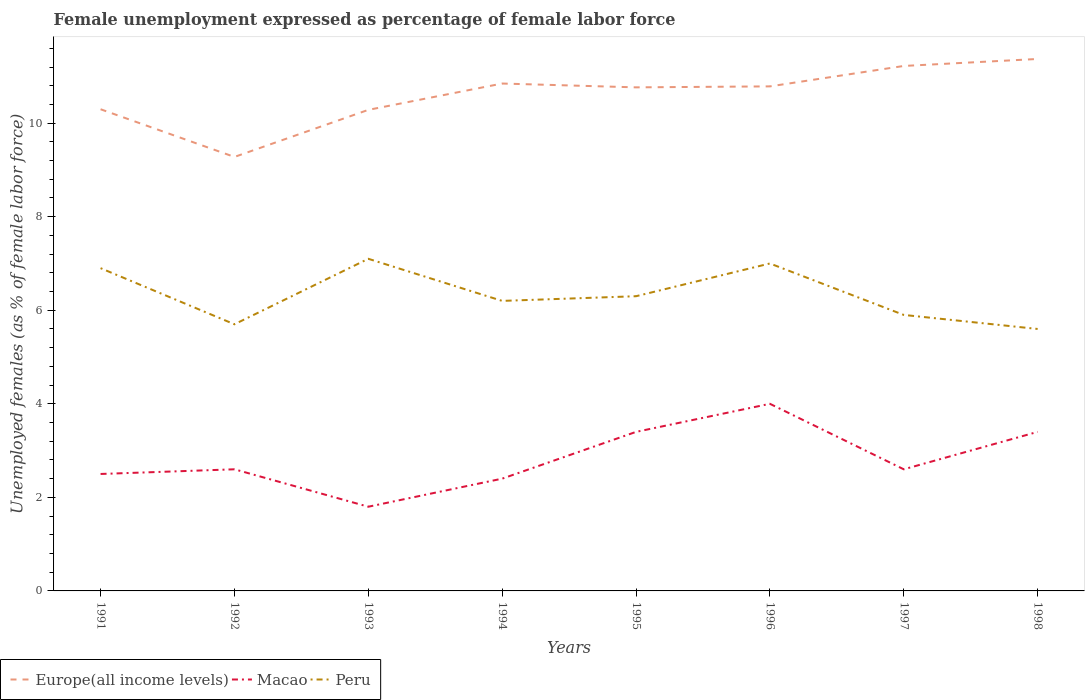How many different coloured lines are there?
Your answer should be compact. 3. Across all years, what is the maximum unemployment in females in in Europe(all income levels)?
Your answer should be compact. 9.28. What is the total unemployment in females in in Peru in the graph?
Make the answer very short. 1.2. What is the difference between the highest and the second highest unemployment in females in in Macao?
Keep it short and to the point. 2.2. What is the difference between the highest and the lowest unemployment in females in in Peru?
Provide a succinct answer. 3. How many years are there in the graph?
Your response must be concise. 8. Where does the legend appear in the graph?
Keep it short and to the point. Bottom left. How many legend labels are there?
Your answer should be very brief. 3. How are the legend labels stacked?
Provide a short and direct response. Horizontal. What is the title of the graph?
Keep it short and to the point. Female unemployment expressed as percentage of female labor force. What is the label or title of the X-axis?
Your answer should be compact. Years. What is the label or title of the Y-axis?
Keep it short and to the point. Unemployed females (as % of female labor force). What is the Unemployed females (as % of female labor force) in Europe(all income levels) in 1991?
Ensure brevity in your answer.  10.3. What is the Unemployed females (as % of female labor force) in Peru in 1991?
Make the answer very short. 6.9. What is the Unemployed females (as % of female labor force) of Europe(all income levels) in 1992?
Provide a succinct answer. 9.28. What is the Unemployed females (as % of female labor force) of Macao in 1992?
Offer a very short reply. 2.6. What is the Unemployed females (as % of female labor force) in Peru in 1992?
Your answer should be compact. 5.7. What is the Unemployed females (as % of female labor force) of Europe(all income levels) in 1993?
Give a very brief answer. 10.28. What is the Unemployed females (as % of female labor force) in Macao in 1993?
Ensure brevity in your answer.  1.8. What is the Unemployed females (as % of female labor force) of Peru in 1993?
Offer a terse response. 7.1. What is the Unemployed females (as % of female labor force) of Europe(all income levels) in 1994?
Your answer should be compact. 10.85. What is the Unemployed females (as % of female labor force) in Macao in 1994?
Offer a terse response. 2.4. What is the Unemployed females (as % of female labor force) in Peru in 1994?
Provide a short and direct response. 6.2. What is the Unemployed females (as % of female labor force) in Europe(all income levels) in 1995?
Offer a very short reply. 10.76. What is the Unemployed females (as % of female labor force) in Macao in 1995?
Offer a terse response. 3.4. What is the Unemployed females (as % of female labor force) of Peru in 1995?
Your answer should be very brief. 6.3. What is the Unemployed females (as % of female labor force) in Europe(all income levels) in 1996?
Offer a very short reply. 10.79. What is the Unemployed females (as % of female labor force) in Europe(all income levels) in 1997?
Keep it short and to the point. 11.22. What is the Unemployed females (as % of female labor force) in Macao in 1997?
Your answer should be very brief. 2.6. What is the Unemployed females (as % of female labor force) in Peru in 1997?
Keep it short and to the point. 5.9. What is the Unemployed females (as % of female labor force) in Europe(all income levels) in 1998?
Provide a short and direct response. 11.37. What is the Unemployed females (as % of female labor force) in Macao in 1998?
Provide a short and direct response. 3.4. What is the Unemployed females (as % of female labor force) of Peru in 1998?
Your answer should be very brief. 5.6. Across all years, what is the maximum Unemployed females (as % of female labor force) in Europe(all income levels)?
Make the answer very short. 11.37. Across all years, what is the maximum Unemployed females (as % of female labor force) in Peru?
Provide a succinct answer. 7.1. Across all years, what is the minimum Unemployed females (as % of female labor force) of Europe(all income levels)?
Your answer should be very brief. 9.28. Across all years, what is the minimum Unemployed females (as % of female labor force) of Macao?
Keep it short and to the point. 1.8. Across all years, what is the minimum Unemployed females (as % of female labor force) in Peru?
Offer a very short reply. 5.6. What is the total Unemployed females (as % of female labor force) of Europe(all income levels) in the graph?
Keep it short and to the point. 84.85. What is the total Unemployed females (as % of female labor force) in Macao in the graph?
Give a very brief answer. 22.7. What is the total Unemployed females (as % of female labor force) of Peru in the graph?
Ensure brevity in your answer.  50.7. What is the difference between the Unemployed females (as % of female labor force) in Europe(all income levels) in 1991 and that in 1992?
Provide a succinct answer. 1.02. What is the difference between the Unemployed females (as % of female labor force) of Europe(all income levels) in 1991 and that in 1993?
Offer a very short reply. 0.01. What is the difference between the Unemployed females (as % of female labor force) of Macao in 1991 and that in 1993?
Your answer should be very brief. 0.7. What is the difference between the Unemployed females (as % of female labor force) of Europe(all income levels) in 1991 and that in 1994?
Your response must be concise. -0.55. What is the difference between the Unemployed females (as % of female labor force) in Macao in 1991 and that in 1994?
Give a very brief answer. 0.1. What is the difference between the Unemployed females (as % of female labor force) of Europe(all income levels) in 1991 and that in 1995?
Ensure brevity in your answer.  -0.47. What is the difference between the Unemployed females (as % of female labor force) of Macao in 1991 and that in 1995?
Give a very brief answer. -0.9. What is the difference between the Unemployed females (as % of female labor force) in Peru in 1991 and that in 1995?
Keep it short and to the point. 0.6. What is the difference between the Unemployed females (as % of female labor force) in Europe(all income levels) in 1991 and that in 1996?
Provide a succinct answer. -0.49. What is the difference between the Unemployed females (as % of female labor force) of Macao in 1991 and that in 1996?
Offer a very short reply. -1.5. What is the difference between the Unemployed females (as % of female labor force) of Peru in 1991 and that in 1996?
Offer a terse response. -0.1. What is the difference between the Unemployed females (as % of female labor force) in Europe(all income levels) in 1991 and that in 1997?
Your response must be concise. -0.93. What is the difference between the Unemployed females (as % of female labor force) of Macao in 1991 and that in 1997?
Your answer should be very brief. -0.1. What is the difference between the Unemployed females (as % of female labor force) of Europe(all income levels) in 1991 and that in 1998?
Make the answer very short. -1.07. What is the difference between the Unemployed females (as % of female labor force) in Europe(all income levels) in 1992 and that in 1993?
Your response must be concise. -1.01. What is the difference between the Unemployed females (as % of female labor force) of Macao in 1992 and that in 1993?
Provide a succinct answer. 0.8. What is the difference between the Unemployed females (as % of female labor force) of Europe(all income levels) in 1992 and that in 1994?
Your answer should be very brief. -1.57. What is the difference between the Unemployed females (as % of female labor force) of Peru in 1992 and that in 1994?
Offer a very short reply. -0.5. What is the difference between the Unemployed females (as % of female labor force) in Europe(all income levels) in 1992 and that in 1995?
Provide a short and direct response. -1.49. What is the difference between the Unemployed females (as % of female labor force) of Europe(all income levels) in 1992 and that in 1996?
Provide a succinct answer. -1.51. What is the difference between the Unemployed females (as % of female labor force) in Macao in 1992 and that in 1996?
Your answer should be very brief. -1.4. What is the difference between the Unemployed females (as % of female labor force) of Europe(all income levels) in 1992 and that in 1997?
Give a very brief answer. -1.95. What is the difference between the Unemployed females (as % of female labor force) in Macao in 1992 and that in 1997?
Provide a succinct answer. 0. What is the difference between the Unemployed females (as % of female labor force) in Europe(all income levels) in 1992 and that in 1998?
Give a very brief answer. -2.09. What is the difference between the Unemployed females (as % of female labor force) of Europe(all income levels) in 1993 and that in 1994?
Offer a terse response. -0.56. What is the difference between the Unemployed females (as % of female labor force) in Europe(all income levels) in 1993 and that in 1995?
Keep it short and to the point. -0.48. What is the difference between the Unemployed females (as % of female labor force) of Macao in 1993 and that in 1995?
Give a very brief answer. -1.6. What is the difference between the Unemployed females (as % of female labor force) in Europe(all income levels) in 1993 and that in 1996?
Keep it short and to the point. -0.5. What is the difference between the Unemployed females (as % of female labor force) of Peru in 1993 and that in 1996?
Provide a succinct answer. 0.1. What is the difference between the Unemployed females (as % of female labor force) in Europe(all income levels) in 1993 and that in 1997?
Provide a succinct answer. -0.94. What is the difference between the Unemployed females (as % of female labor force) of Europe(all income levels) in 1993 and that in 1998?
Your answer should be compact. -1.09. What is the difference between the Unemployed females (as % of female labor force) of Macao in 1993 and that in 1998?
Provide a succinct answer. -1.6. What is the difference between the Unemployed females (as % of female labor force) in Peru in 1993 and that in 1998?
Your response must be concise. 1.5. What is the difference between the Unemployed females (as % of female labor force) of Europe(all income levels) in 1994 and that in 1995?
Your response must be concise. 0.08. What is the difference between the Unemployed females (as % of female labor force) in Macao in 1994 and that in 1995?
Your answer should be compact. -1. What is the difference between the Unemployed females (as % of female labor force) in Peru in 1994 and that in 1995?
Make the answer very short. -0.1. What is the difference between the Unemployed females (as % of female labor force) in Europe(all income levels) in 1994 and that in 1996?
Your response must be concise. 0.06. What is the difference between the Unemployed females (as % of female labor force) of Macao in 1994 and that in 1996?
Your answer should be very brief. -1.6. What is the difference between the Unemployed females (as % of female labor force) in Europe(all income levels) in 1994 and that in 1997?
Your answer should be very brief. -0.38. What is the difference between the Unemployed females (as % of female labor force) in Peru in 1994 and that in 1997?
Offer a terse response. 0.3. What is the difference between the Unemployed females (as % of female labor force) in Europe(all income levels) in 1994 and that in 1998?
Give a very brief answer. -0.53. What is the difference between the Unemployed females (as % of female labor force) in Peru in 1994 and that in 1998?
Provide a succinct answer. 0.6. What is the difference between the Unemployed females (as % of female labor force) of Europe(all income levels) in 1995 and that in 1996?
Ensure brevity in your answer.  -0.02. What is the difference between the Unemployed females (as % of female labor force) in Macao in 1995 and that in 1996?
Provide a short and direct response. -0.6. What is the difference between the Unemployed females (as % of female labor force) of Peru in 1995 and that in 1996?
Provide a succinct answer. -0.7. What is the difference between the Unemployed females (as % of female labor force) in Europe(all income levels) in 1995 and that in 1997?
Your answer should be compact. -0.46. What is the difference between the Unemployed females (as % of female labor force) in Macao in 1995 and that in 1997?
Your answer should be very brief. 0.8. What is the difference between the Unemployed females (as % of female labor force) of Europe(all income levels) in 1995 and that in 1998?
Offer a terse response. -0.61. What is the difference between the Unemployed females (as % of female labor force) in Europe(all income levels) in 1996 and that in 1997?
Your answer should be very brief. -0.44. What is the difference between the Unemployed females (as % of female labor force) in Peru in 1996 and that in 1997?
Your response must be concise. 1.1. What is the difference between the Unemployed females (as % of female labor force) of Europe(all income levels) in 1996 and that in 1998?
Offer a terse response. -0.59. What is the difference between the Unemployed females (as % of female labor force) in Europe(all income levels) in 1997 and that in 1998?
Give a very brief answer. -0.15. What is the difference between the Unemployed females (as % of female labor force) in Macao in 1997 and that in 1998?
Offer a terse response. -0.8. What is the difference between the Unemployed females (as % of female labor force) in Peru in 1997 and that in 1998?
Give a very brief answer. 0.3. What is the difference between the Unemployed females (as % of female labor force) in Europe(all income levels) in 1991 and the Unemployed females (as % of female labor force) in Macao in 1992?
Keep it short and to the point. 7.7. What is the difference between the Unemployed females (as % of female labor force) of Europe(all income levels) in 1991 and the Unemployed females (as % of female labor force) of Peru in 1992?
Your response must be concise. 4.6. What is the difference between the Unemployed females (as % of female labor force) of Macao in 1991 and the Unemployed females (as % of female labor force) of Peru in 1992?
Offer a very short reply. -3.2. What is the difference between the Unemployed females (as % of female labor force) of Europe(all income levels) in 1991 and the Unemployed females (as % of female labor force) of Macao in 1993?
Ensure brevity in your answer.  8.5. What is the difference between the Unemployed females (as % of female labor force) of Europe(all income levels) in 1991 and the Unemployed females (as % of female labor force) of Peru in 1993?
Provide a short and direct response. 3.2. What is the difference between the Unemployed females (as % of female labor force) in Europe(all income levels) in 1991 and the Unemployed females (as % of female labor force) in Macao in 1994?
Your answer should be very brief. 7.9. What is the difference between the Unemployed females (as % of female labor force) in Europe(all income levels) in 1991 and the Unemployed females (as % of female labor force) in Peru in 1994?
Offer a very short reply. 4.1. What is the difference between the Unemployed females (as % of female labor force) in Macao in 1991 and the Unemployed females (as % of female labor force) in Peru in 1994?
Your answer should be very brief. -3.7. What is the difference between the Unemployed females (as % of female labor force) of Europe(all income levels) in 1991 and the Unemployed females (as % of female labor force) of Macao in 1995?
Offer a very short reply. 6.9. What is the difference between the Unemployed females (as % of female labor force) of Europe(all income levels) in 1991 and the Unemployed females (as % of female labor force) of Peru in 1995?
Give a very brief answer. 4. What is the difference between the Unemployed females (as % of female labor force) of Europe(all income levels) in 1991 and the Unemployed females (as % of female labor force) of Macao in 1996?
Ensure brevity in your answer.  6.3. What is the difference between the Unemployed females (as % of female labor force) of Europe(all income levels) in 1991 and the Unemployed females (as % of female labor force) of Peru in 1996?
Ensure brevity in your answer.  3.3. What is the difference between the Unemployed females (as % of female labor force) of Macao in 1991 and the Unemployed females (as % of female labor force) of Peru in 1996?
Offer a very short reply. -4.5. What is the difference between the Unemployed females (as % of female labor force) in Europe(all income levels) in 1991 and the Unemployed females (as % of female labor force) in Macao in 1997?
Your response must be concise. 7.7. What is the difference between the Unemployed females (as % of female labor force) of Europe(all income levels) in 1991 and the Unemployed females (as % of female labor force) of Peru in 1997?
Provide a succinct answer. 4.4. What is the difference between the Unemployed females (as % of female labor force) in Europe(all income levels) in 1991 and the Unemployed females (as % of female labor force) in Macao in 1998?
Offer a very short reply. 6.9. What is the difference between the Unemployed females (as % of female labor force) in Europe(all income levels) in 1991 and the Unemployed females (as % of female labor force) in Peru in 1998?
Offer a terse response. 4.7. What is the difference between the Unemployed females (as % of female labor force) of Europe(all income levels) in 1992 and the Unemployed females (as % of female labor force) of Macao in 1993?
Make the answer very short. 7.48. What is the difference between the Unemployed females (as % of female labor force) of Europe(all income levels) in 1992 and the Unemployed females (as % of female labor force) of Peru in 1993?
Provide a succinct answer. 2.18. What is the difference between the Unemployed females (as % of female labor force) in Europe(all income levels) in 1992 and the Unemployed females (as % of female labor force) in Macao in 1994?
Provide a succinct answer. 6.88. What is the difference between the Unemployed females (as % of female labor force) in Europe(all income levels) in 1992 and the Unemployed females (as % of female labor force) in Peru in 1994?
Your response must be concise. 3.08. What is the difference between the Unemployed females (as % of female labor force) in Europe(all income levels) in 1992 and the Unemployed females (as % of female labor force) in Macao in 1995?
Your answer should be very brief. 5.88. What is the difference between the Unemployed females (as % of female labor force) in Europe(all income levels) in 1992 and the Unemployed females (as % of female labor force) in Peru in 1995?
Make the answer very short. 2.98. What is the difference between the Unemployed females (as % of female labor force) of Europe(all income levels) in 1992 and the Unemployed females (as % of female labor force) of Macao in 1996?
Make the answer very short. 5.28. What is the difference between the Unemployed females (as % of female labor force) in Europe(all income levels) in 1992 and the Unemployed females (as % of female labor force) in Peru in 1996?
Your response must be concise. 2.28. What is the difference between the Unemployed females (as % of female labor force) of Macao in 1992 and the Unemployed females (as % of female labor force) of Peru in 1996?
Make the answer very short. -4.4. What is the difference between the Unemployed females (as % of female labor force) in Europe(all income levels) in 1992 and the Unemployed females (as % of female labor force) in Macao in 1997?
Your answer should be very brief. 6.68. What is the difference between the Unemployed females (as % of female labor force) of Europe(all income levels) in 1992 and the Unemployed females (as % of female labor force) of Peru in 1997?
Your answer should be compact. 3.38. What is the difference between the Unemployed females (as % of female labor force) in Europe(all income levels) in 1992 and the Unemployed females (as % of female labor force) in Macao in 1998?
Provide a short and direct response. 5.88. What is the difference between the Unemployed females (as % of female labor force) of Europe(all income levels) in 1992 and the Unemployed females (as % of female labor force) of Peru in 1998?
Your answer should be very brief. 3.68. What is the difference between the Unemployed females (as % of female labor force) in Macao in 1992 and the Unemployed females (as % of female labor force) in Peru in 1998?
Provide a short and direct response. -3. What is the difference between the Unemployed females (as % of female labor force) of Europe(all income levels) in 1993 and the Unemployed females (as % of female labor force) of Macao in 1994?
Your answer should be compact. 7.88. What is the difference between the Unemployed females (as % of female labor force) of Europe(all income levels) in 1993 and the Unemployed females (as % of female labor force) of Peru in 1994?
Provide a succinct answer. 4.08. What is the difference between the Unemployed females (as % of female labor force) in Europe(all income levels) in 1993 and the Unemployed females (as % of female labor force) in Macao in 1995?
Provide a succinct answer. 6.88. What is the difference between the Unemployed females (as % of female labor force) in Europe(all income levels) in 1993 and the Unemployed females (as % of female labor force) in Peru in 1995?
Ensure brevity in your answer.  3.98. What is the difference between the Unemployed females (as % of female labor force) in Europe(all income levels) in 1993 and the Unemployed females (as % of female labor force) in Macao in 1996?
Provide a succinct answer. 6.28. What is the difference between the Unemployed females (as % of female labor force) in Europe(all income levels) in 1993 and the Unemployed females (as % of female labor force) in Peru in 1996?
Ensure brevity in your answer.  3.28. What is the difference between the Unemployed females (as % of female labor force) in Europe(all income levels) in 1993 and the Unemployed females (as % of female labor force) in Macao in 1997?
Ensure brevity in your answer.  7.68. What is the difference between the Unemployed females (as % of female labor force) of Europe(all income levels) in 1993 and the Unemployed females (as % of female labor force) of Peru in 1997?
Provide a succinct answer. 4.38. What is the difference between the Unemployed females (as % of female labor force) in Europe(all income levels) in 1993 and the Unemployed females (as % of female labor force) in Macao in 1998?
Provide a succinct answer. 6.88. What is the difference between the Unemployed females (as % of female labor force) in Europe(all income levels) in 1993 and the Unemployed females (as % of female labor force) in Peru in 1998?
Offer a very short reply. 4.68. What is the difference between the Unemployed females (as % of female labor force) in Europe(all income levels) in 1994 and the Unemployed females (as % of female labor force) in Macao in 1995?
Provide a succinct answer. 7.45. What is the difference between the Unemployed females (as % of female labor force) in Europe(all income levels) in 1994 and the Unemployed females (as % of female labor force) in Peru in 1995?
Ensure brevity in your answer.  4.55. What is the difference between the Unemployed females (as % of female labor force) of Macao in 1994 and the Unemployed females (as % of female labor force) of Peru in 1995?
Keep it short and to the point. -3.9. What is the difference between the Unemployed females (as % of female labor force) of Europe(all income levels) in 1994 and the Unemployed females (as % of female labor force) of Macao in 1996?
Ensure brevity in your answer.  6.85. What is the difference between the Unemployed females (as % of female labor force) in Europe(all income levels) in 1994 and the Unemployed females (as % of female labor force) in Peru in 1996?
Keep it short and to the point. 3.85. What is the difference between the Unemployed females (as % of female labor force) in Europe(all income levels) in 1994 and the Unemployed females (as % of female labor force) in Macao in 1997?
Your response must be concise. 8.25. What is the difference between the Unemployed females (as % of female labor force) in Europe(all income levels) in 1994 and the Unemployed females (as % of female labor force) in Peru in 1997?
Your answer should be compact. 4.95. What is the difference between the Unemployed females (as % of female labor force) in Europe(all income levels) in 1994 and the Unemployed females (as % of female labor force) in Macao in 1998?
Your answer should be very brief. 7.45. What is the difference between the Unemployed females (as % of female labor force) in Europe(all income levels) in 1994 and the Unemployed females (as % of female labor force) in Peru in 1998?
Your answer should be compact. 5.25. What is the difference between the Unemployed females (as % of female labor force) of Europe(all income levels) in 1995 and the Unemployed females (as % of female labor force) of Macao in 1996?
Keep it short and to the point. 6.76. What is the difference between the Unemployed females (as % of female labor force) in Europe(all income levels) in 1995 and the Unemployed females (as % of female labor force) in Peru in 1996?
Your answer should be compact. 3.76. What is the difference between the Unemployed females (as % of female labor force) of Europe(all income levels) in 1995 and the Unemployed females (as % of female labor force) of Macao in 1997?
Give a very brief answer. 8.16. What is the difference between the Unemployed females (as % of female labor force) of Europe(all income levels) in 1995 and the Unemployed females (as % of female labor force) of Peru in 1997?
Ensure brevity in your answer.  4.86. What is the difference between the Unemployed females (as % of female labor force) of Macao in 1995 and the Unemployed females (as % of female labor force) of Peru in 1997?
Offer a very short reply. -2.5. What is the difference between the Unemployed females (as % of female labor force) of Europe(all income levels) in 1995 and the Unemployed females (as % of female labor force) of Macao in 1998?
Give a very brief answer. 7.36. What is the difference between the Unemployed females (as % of female labor force) of Europe(all income levels) in 1995 and the Unemployed females (as % of female labor force) of Peru in 1998?
Your response must be concise. 5.16. What is the difference between the Unemployed females (as % of female labor force) of Macao in 1995 and the Unemployed females (as % of female labor force) of Peru in 1998?
Your response must be concise. -2.2. What is the difference between the Unemployed females (as % of female labor force) of Europe(all income levels) in 1996 and the Unemployed females (as % of female labor force) of Macao in 1997?
Your response must be concise. 8.19. What is the difference between the Unemployed females (as % of female labor force) in Europe(all income levels) in 1996 and the Unemployed females (as % of female labor force) in Peru in 1997?
Your response must be concise. 4.89. What is the difference between the Unemployed females (as % of female labor force) in Europe(all income levels) in 1996 and the Unemployed females (as % of female labor force) in Macao in 1998?
Your response must be concise. 7.39. What is the difference between the Unemployed females (as % of female labor force) of Europe(all income levels) in 1996 and the Unemployed females (as % of female labor force) of Peru in 1998?
Make the answer very short. 5.19. What is the difference between the Unemployed females (as % of female labor force) of Macao in 1996 and the Unemployed females (as % of female labor force) of Peru in 1998?
Make the answer very short. -1.6. What is the difference between the Unemployed females (as % of female labor force) in Europe(all income levels) in 1997 and the Unemployed females (as % of female labor force) in Macao in 1998?
Provide a succinct answer. 7.82. What is the difference between the Unemployed females (as % of female labor force) of Europe(all income levels) in 1997 and the Unemployed females (as % of female labor force) of Peru in 1998?
Your answer should be compact. 5.62. What is the average Unemployed females (as % of female labor force) of Europe(all income levels) per year?
Offer a very short reply. 10.61. What is the average Unemployed females (as % of female labor force) of Macao per year?
Your answer should be compact. 2.84. What is the average Unemployed females (as % of female labor force) in Peru per year?
Give a very brief answer. 6.34. In the year 1991, what is the difference between the Unemployed females (as % of female labor force) of Europe(all income levels) and Unemployed females (as % of female labor force) of Macao?
Give a very brief answer. 7.8. In the year 1991, what is the difference between the Unemployed females (as % of female labor force) of Europe(all income levels) and Unemployed females (as % of female labor force) of Peru?
Your answer should be compact. 3.4. In the year 1991, what is the difference between the Unemployed females (as % of female labor force) of Macao and Unemployed females (as % of female labor force) of Peru?
Offer a very short reply. -4.4. In the year 1992, what is the difference between the Unemployed females (as % of female labor force) in Europe(all income levels) and Unemployed females (as % of female labor force) in Macao?
Give a very brief answer. 6.68. In the year 1992, what is the difference between the Unemployed females (as % of female labor force) in Europe(all income levels) and Unemployed females (as % of female labor force) in Peru?
Your response must be concise. 3.58. In the year 1993, what is the difference between the Unemployed females (as % of female labor force) in Europe(all income levels) and Unemployed females (as % of female labor force) in Macao?
Your response must be concise. 8.48. In the year 1993, what is the difference between the Unemployed females (as % of female labor force) in Europe(all income levels) and Unemployed females (as % of female labor force) in Peru?
Provide a succinct answer. 3.18. In the year 1993, what is the difference between the Unemployed females (as % of female labor force) of Macao and Unemployed females (as % of female labor force) of Peru?
Give a very brief answer. -5.3. In the year 1994, what is the difference between the Unemployed females (as % of female labor force) in Europe(all income levels) and Unemployed females (as % of female labor force) in Macao?
Your answer should be compact. 8.45. In the year 1994, what is the difference between the Unemployed females (as % of female labor force) of Europe(all income levels) and Unemployed females (as % of female labor force) of Peru?
Give a very brief answer. 4.65. In the year 1994, what is the difference between the Unemployed females (as % of female labor force) of Macao and Unemployed females (as % of female labor force) of Peru?
Keep it short and to the point. -3.8. In the year 1995, what is the difference between the Unemployed females (as % of female labor force) of Europe(all income levels) and Unemployed females (as % of female labor force) of Macao?
Ensure brevity in your answer.  7.36. In the year 1995, what is the difference between the Unemployed females (as % of female labor force) of Europe(all income levels) and Unemployed females (as % of female labor force) of Peru?
Give a very brief answer. 4.46. In the year 1995, what is the difference between the Unemployed females (as % of female labor force) in Macao and Unemployed females (as % of female labor force) in Peru?
Offer a terse response. -2.9. In the year 1996, what is the difference between the Unemployed females (as % of female labor force) of Europe(all income levels) and Unemployed females (as % of female labor force) of Macao?
Keep it short and to the point. 6.79. In the year 1996, what is the difference between the Unemployed females (as % of female labor force) in Europe(all income levels) and Unemployed females (as % of female labor force) in Peru?
Provide a short and direct response. 3.79. In the year 1996, what is the difference between the Unemployed females (as % of female labor force) in Macao and Unemployed females (as % of female labor force) in Peru?
Your response must be concise. -3. In the year 1997, what is the difference between the Unemployed females (as % of female labor force) in Europe(all income levels) and Unemployed females (as % of female labor force) in Macao?
Offer a terse response. 8.62. In the year 1997, what is the difference between the Unemployed females (as % of female labor force) of Europe(all income levels) and Unemployed females (as % of female labor force) of Peru?
Your answer should be compact. 5.32. In the year 1997, what is the difference between the Unemployed females (as % of female labor force) of Macao and Unemployed females (as % of female labor force) of Peru?
Ensure brevity in your answer.  -3.3. In the year 1998, what is the difference between the Unemployed females (as % of female labor force) in Europe(all income levels) and Unemployed females (as % of female labor force) in Macao?
Offer a terse response. 7.97. In the year 1998, what is the difference between the Unemployed females (as % of female labor force) in Europe(all income levels) and Unemployed females (as % of female labor force) in Peru?
Make the answer very short. 5.77. What is the ratio of the Unemployed females (as % of female labor force) of Europe(all income levels) in 1991 to that in 1992?
Your answer should be very brief. 1.11. What is the ratio of the Unemployed females (as % of female labor force) in Macao in 1991 to that in 1992?
Offer a terse response. 0.96. What is the ratio of the Unemployed females (as % of female labor force) in Peru in 1991 to that in 1992?
Your response must be concise. 1.21. What is the ratio of the Unemployed females (as % of female labor force) in Europe(all income levels) in 1991 to that in 1993?
Your response must be concise. 1. What is the ratio of the Unemployed females (as % of female labor force) in Macao in 1991 to that in 1993?
Offer a terse response. 1.39. What is the ratio of the Unemployed females (as % of female labor force) of Peru in 1991 to that in 1993?
Offer a very short reply. 0.97. What is the ratio of the Unemployed females (as % of female labor force) in Europe(all income levels) in 1991 to that in 1994?
Ensure brevity in your answer.  0.95. What is the ratio of the Unemployed females (as % of female labor force) in Macao in 1991 to that in 1994?
Provide a short and direct response. 1.04. What is the ratio of the Unemployed females (as % of female labor force) of Peru in 1991 to that in 1994?
Your response must be concise. 1.11. What is the ratio of the Unemployed females (as % of female labor force) in Europe(all income levels) in 1991 to that in 1995?
Offer a very short reply. 0.96. What is the ratio of the Unemployed females (as % of female labor force) in Macao in 1991 to that in 1995?
Offer a very short reply. 0.74. What is the ratio of the Unemployed females (as % of female labor force) of Peru in 1991 to that in 1995?
Ensure brevity in your answer.  1.1. What is the ratio of the Unemployed females (as % of female labor force) in Europe(all income levels) in 1991 to that in 1996?
Offer a very short reply. 0.95. What is the ratio of the Unemployed females (as % of female labor force) in Peru in 1991 to that in 1996?
Make the answer very short. 0.99. What is the ratio of the Unemployed females (as % of female labor force) of Europe(all income levels) in 1991 to that in 1997?
Make the answer very short. 0.92. What is the ratio of the Unemployed females (as % of female labor force) in Macao in 1991 to that in 1997?
Ensure brevity in your answer.  0.96. What is the ratio of the Unemployed females (as % of female labor force) in Peru in 1991 to that in 1997?
Offer a very short reply. 1.17. What is the ratio of the Unemployed females (as % of female labor force) in Europe(all income levels) in 1991 to that in 1998?
Ensure brevity in your answer.  0.91. What is the ratio of the Unemployed females (as % of female labor force) of Macao in 1991 to that in 1998?
Your response must be concise. 0.74. What is the ratio of the Unemployed females (as % of female labor force) of Peru in 1991 to that in 1998?
Your response must be concise. 1.23. What is the ratio of the Unemployed females (as % of female labor force) in Europe(all income levels) in 1992 to that in 1993?
Offer a terse response. 0.9. What is the ratio of the Unemployed females (as % of female labor force) of Macao in 1992 to that in 1993?
Keep it short and to the point. 1.44. What is the ratio of the Unemployed females (as % of female labor force) in Peru in 1992 to that in 1993?
Your response must be concise. 0.8. What is the ratio of the Unemployed females (as % of female labor force) in Europe(all income levels) in 1992 to that in 1994?
Ensure brevity in your answer.  0.86. What is the ratio of the Unemployed females (as % of female labor force) in Peru in 1992 to that in 1994?
Your answer should be very brief. 0.92. What is the ratio of the Unemployed females (as % of female labor force) in Europe(all income levels) in 1992 to that in 1995?
Ensure brevity in your answer.  0.86. What is the ratio of the Unemployed females (as % of female labor force) in Macao in 1992 to that in 1995?
Make the answer very short. 0.76. What is the ratio of the Unemployed females (as % of female labor force) in Peru in 1992 to that in 1995?
Ensure brevity in your answer.  0.9. What is the ratio of the Unemployed females (as % of female labor force) of Europe(all income levels) in 1992 to that in 1996?
Your answer should be very brief. 0.86. What is the ratio of the Unemployed females (as % of female labor force) of Macao in 1992 to that in 1996?
Your response must be concise. 0.65. What is the ratio of the Unemployed females (as % of female labor force) of Peru in 1992 to that in 1996?
Provide a short and direct response. 0.81. What is the ratio of the Unemployed females (as % of female labor force) in Europe(all income levels) in 1992 to that in 1997?
Your answer should be compact. 0.83. What is the ratio of the Unemployed females (as % of female labor force) of Macao in 1992 to that in 1997?
Offer a terse response. 1. What is the ratio of the Unemployed females (as % of female labor force) of Peru in 1992 to that in 1997?
Offer a very short reply. 0.97. What is the ratio of the Unemployed females (as % of female labor force) of Europe(all income levels) in 1992 to that in 1998?
Offer a terse response. 0.82. What is the ratio of the Unemployed females (as % of female labor force) in Macao in 1992 to that in 1998?
Give a very brief answer. 0.76. What is the ratio of the Unemployed females (as % of female labor force) of Peru in 1992 to that in 1998?
Offer a terse response. 1.02. What is the ratio of the Unemployed females (as % of female labor force) of Europe(all income levels) in 1993 to that in 1994?
Give a very brief answer. 0.95. What is the ratio of the Unemployed females (as % of female labor force) in Peru in 1993 to that in 1994?
Give a very brief answer. 1.15. What is the ratio of the Unemployed females (as % of female labor force) in Europe(all income levels) in 1993 to that in 1995?
Your answer should be very brief. 0.96. What is the ratio of the Unemployed females (as % of female labor force) of Macao in 1993 to that in 1995?
Provide a short and direct response. 0.53. What is the ratio of the Unemployed females (as % of female labor force) in Peru in 1993 to that in 1995?
Make the answer very short. 1.13. What is the ratio of the Unemployed females (as % of female labor force) in Europe(all income levels) in 1993 to that in 1996?
Your response must be concise. 0.95. What is the ratio of the Unemployed females (as % of female labor force) of Macao in 1993 to that in 1996?
Make the answer very short. 0.45. What is the ratio of the Unemployed females (as % of female labor force) of Peru in 1993 to that in 1996?
Make the answer very short. 1.01. What is the ratio of the Unemployed females (as % of female labor force) in Europe(all income levels) in 1993 to that in 1997?
Your answer should be very brief. 0.92. What is the ratio of the Unemployed females (as % of female labor force) in Macao in 1993 to that in 1997?
Your response must be concise. 0.69. What is the ratio of the Unemployed females (as % of female labor force) in Peru in 1993 to that in 1997?
Give a very brief answer. 1.2. What is the ratio of the Unemployed females (as % of female labor force) in Europe(all income levels) in 1993 to that in 1998?
Provide a succinct answer. 0.9. What is the ratio of the Unemployed females (as % of female labor force) in Macao in 1993 to that in 1998?
Keep it short and to the point. 0.53. What is the ratio of the Unemployed females (as % of female labor force) of Peru in 1993 to that in 1998?
Your response must be concise. 1.27. What is the ratio of the Unemployed females (as % of female labor force) in Europe(all income levels) in 1994 to that in 1995?
Your answer should be very brief. 1.01. What is the ratio of the Unemployed females (as % of female labor force) of Macao in 1994 to that in 1995?
Offer a very short reply. 0.71. What is the ratio of the Unemployed females (as % of female labor force) of Peru in 1994 to that in 1995?
Offer a very short reply. 0.98. What is the ratio of the Unemployed females (as % of female labor force) in Europe(all income levels) in 1994 to that in 1996?
Provide a short and direct response. 1.01. What is the ratio of the Unemployed females (as % of female labor force) in Peru in 1994 to that in 1996?
Offer a very short reply. 0.89. What is the ratio of the Unemployed females (as % of female labor force) in Europe(all income levels) in 1994 to that in 1997?
Provide a short and direct response. 0.97. What is the ratio of the Unemployed females (as % of female labor force) of Macao in 1994 to that in 1997?
Provide a succinct answer. 0.92. What is the ratio of the Unemployed females (as % of female labor force) of Peru in 1994 to that in 1997?
Your answer should be very brief. 1.05. What is the ratio of the Unemployed females (as % of female labor force) in Europe(all income levels) in 1994 to that in 1998?
Offer a terse response. 0.95. What is the ratio of the Unemployed females (as % of female labor force) of Macao in 1994 to that in 1998?
Keep it short and to the point. 0.71. What is the ratio of the Unemployed females (as % of female labor force) of Peru in 1994 to that in 1998?
Offer a very short reply. 1.11. What is the ratio of the Unemployed females (as % of female labor force) of Europe(all income levels) in 1995 to that in 1997?
Provide a short and direct response. 0.96. What is the ratio of the Unemployed females (as % of female labor force) of Macao in 1995 to that in 1997?
Ensure brevity in your answer.  1.31. What is the ratio of the Unemployed females (as % of female labor force) in Peru in 1995 to that in 1997?
Offer a terse response. 1.07. What is the ratio of the Unemployed females (as % of female labor force) of Europe(all income levels) in 1995 to that in 1998?
Keep it short and to the point. 0.95. What is the ratio of the Unemployed females (as % of female labor force) in Peru in 1995 to that in 1998?
Provide a short and direct response. 1.12. What is the ratio of the Unemployed females (as % of female labor force) in Europe(all income levels) in 1996 to that in 1997?
Offer a very short reply. 0.96. What is the ratio of the Unemployed females (as % of female labor force) in Macao in 1996 to that in 1997?
Your answer should be compact. 1.54. What is the ratio of the Unemployed females (as % of female labor force) of Peru in 1996 to that in 1997?
Ensure brevity in your answer.  1.19. What is the ratio of the Unemployed females (as % of female labor force) of Europe(all income levels) in 1996 to that in 1998?
Your response must be concise. 0.95. What is the ratio of the Unemployed females (as % of female labor force) of Macao in 1996 to that in 1998?
Give a very brief answer. 1.18. What is the ratio of the Unemployed females (as % of female labor force) in Peru in 1996 to that in 1998?
Offer a terse response. 1.25. What is the ratio of the Unemployed females (as % of female labor force) of Europe(all income levels) in 1997 to that in 1998?
Ensure brevity in your answer.  0.99. What is the ratio of the Unemployed females (as % of female labor force) in Macao in 1997 to that in 1998?
Keep it short and to the point. 0.76. What is the ratio of the Unemployed females (as % of female labor force) in Peru in 1997 to that in 1998?
Provide a short and direct response. 1.05. What is the difference between the highest and the second highest Unemployed females (as % of female labor force) of Europe(all income levels)?
Offer a terse response. 0.15. What is the difference between the highest and the second highest Unemployed females (as % of female labor force) in Macao?
Make the answer very short. 0.6. What is the difference between the highest and the second highest Unemployed females (as % of female labor force) of Peru?
Give a very brief answer. 0.1. What is the difference between the highest and the lowest Unemployed females (as % of female labor force) in Europe(all income levels)?
Provide a short and direct response. 2.09. What is the difference between the highest and the lowest Unemployed females (as % of female labor force) in Macao?
Provide a succinct answer. 2.2. What is the difference between the highest and the lowest Unemployed females (as % of female labor force) of Peru?
Make the answer very short. 1.5. 